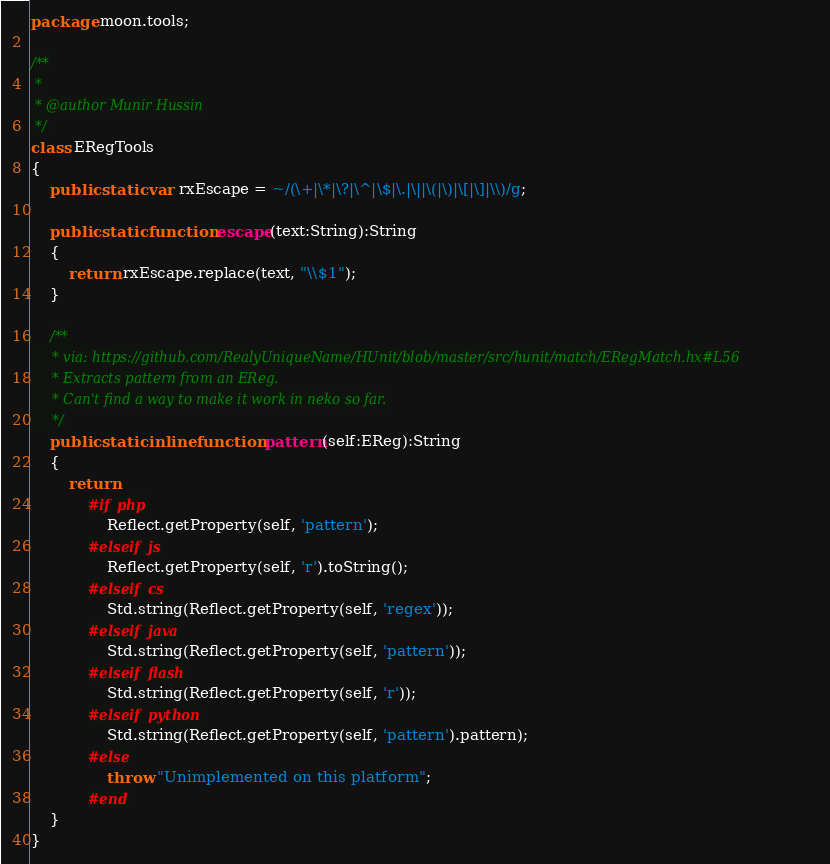<code> <loc_0><loc_0><loc_500><loc_500><_Haxe_>package moon.tools;

/**
 * 
 * @author Munir Hussin
 */
class ERegTools
{
    public static var rxEscape = ~/(\+|\*|\?|\^|\$|\.|\||\(|\)|\[|\]|\\)/g;
    
    public static function escape(text:String):String
    {
        return rxEscape.replace(text, "\\$1");
    }
    
    /**
     * via: https://github.com/RealyUniqueName/HUnit/blob/master/src/hunit/match/ERegMatch.hx#L56
     * Extracts pattern from an EReg.
     * Can't find a way to make it work in neko so far.
     */
    public static inline function pattern(self:EReg):String
    {
        return
            #if php
                Reflect.getProperty(self, 'pattern');
            #elseif js
                Reflect.getProperty(self, 'r').toString();
            #elseif cs
                Std.string(Reflect.getProperty(self, 'regex'));
            #elseif java
                Std.string(Reflect.getProperty(self, 'pattern'));
            #elseif flash
                Std.string(Reflect.getProperty(self, 'r'));
            #elseif python
                Std.string(Reflect.getProperty(self, 'pattern').pattern);
            #else
                throw "Unimplemented on this platform";
            #end
    }
}</code> 